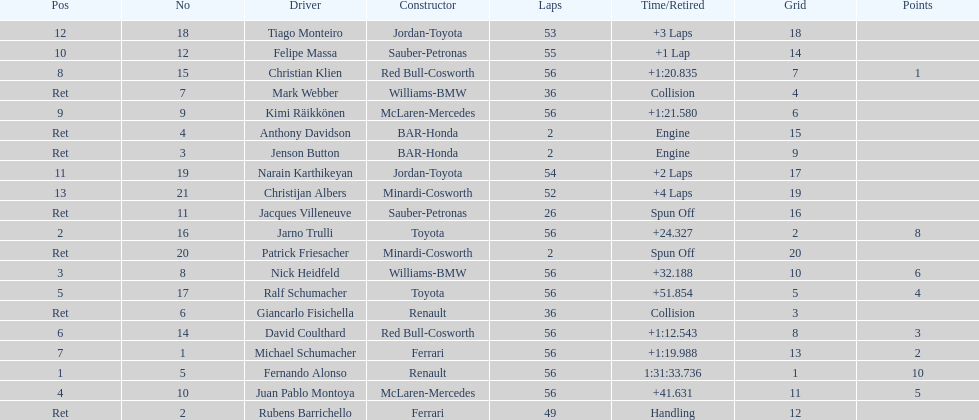How long did it take fernando alonso to finish the race? 1:31:33.736. 